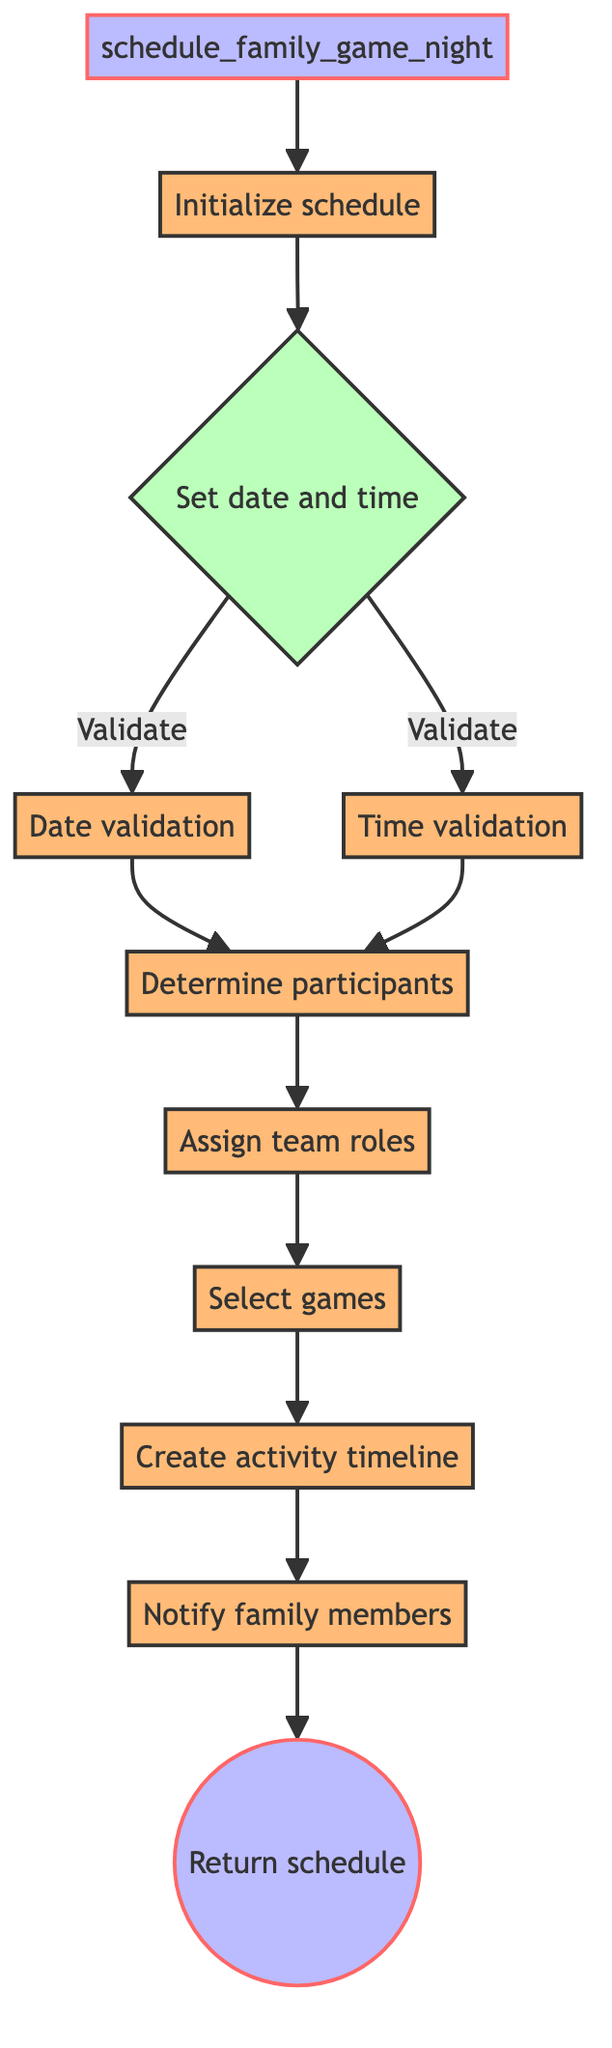what is the first action taken in the flowchart? The first action in the flowchart is to initialize the schedule, represented by the node labeled "Initialize schedule." This indicates that the function starts by creating a new empty schedule.
Answer: Initialize schedule how many validation steps are there before determining participants? The flowchart shows two validation steps: "date validation" and "time validation," both of which are required before moving on to the "Determine participants" node.
Answer: Two what happens after assigning team roles? After assigning team roles, the next step in the flowchart is to "Select games." This indicates that team roles are assigned before choosing the games for the family game night.
Answer: Select games which node comes before notifying family members? The node that comes before notifying family members is "Create activity timeline." This implies that the timeline is established prior to informing the family about the game night schedule.
Answer: Create activity timeline how many input parameters does the schedule_family_game_night function have? According to the diagram, the function "schedule_family_game_night" has three input parameters: date, time, and participants. These inputs are necessary for scheduling the game night.
Answer: Three what do participants validate after setting the date and time? After setting the date and time, participants validate through the "Determine participants" node. This step ensures that the participants for the game night are correctly identified.
Answer: Determine participants which node is labeled with a return function? The node at the end of the flowchart is labeled "Return schedule," indicating the output of the function, which is the finalized schedule for the family game night.
Answer: Return schedule what types of nodes are present in the flowchart? The flowchart contains process nodes for actions like "Initialize schedule" and "Assign team roles," decision nodes like "Set date and time," and input/output nodes for the function name and return. This variety helps depict the function's structure clearly.
Answer: Process, decision, input/output 